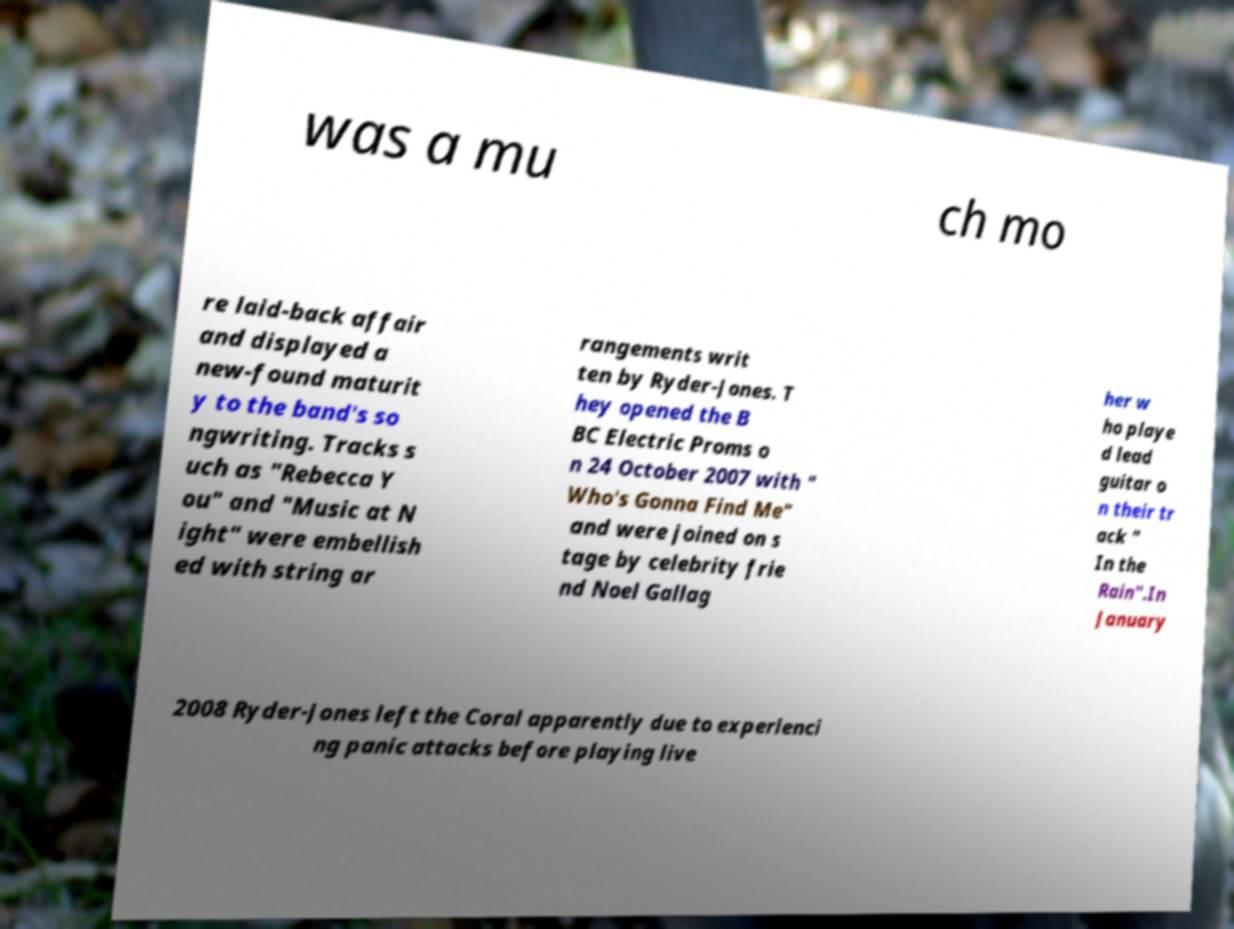I need the written content from this picture converted into text. Can you do that? was a mu ch mo re laid-back affair and displayed a new-found maturit y to the band's so ngwriting. Tracks s uch as "Rebecca Y ou" and "Music at N ight" were embellish ed with string ar rangements writ ten by Ryder-Jones. T hey opened the B BC Electric Proms o n 24 October 2007 with " Who's Gonna Find Me" and were joined on s tage by celebrity frie nd Noel Gallag her w ho playe d lead guitar o n their tr ack " In the Rain".In January 2008 Ryder-Jones left the Coral apparently due to experienci ng panic attacks before playing live 